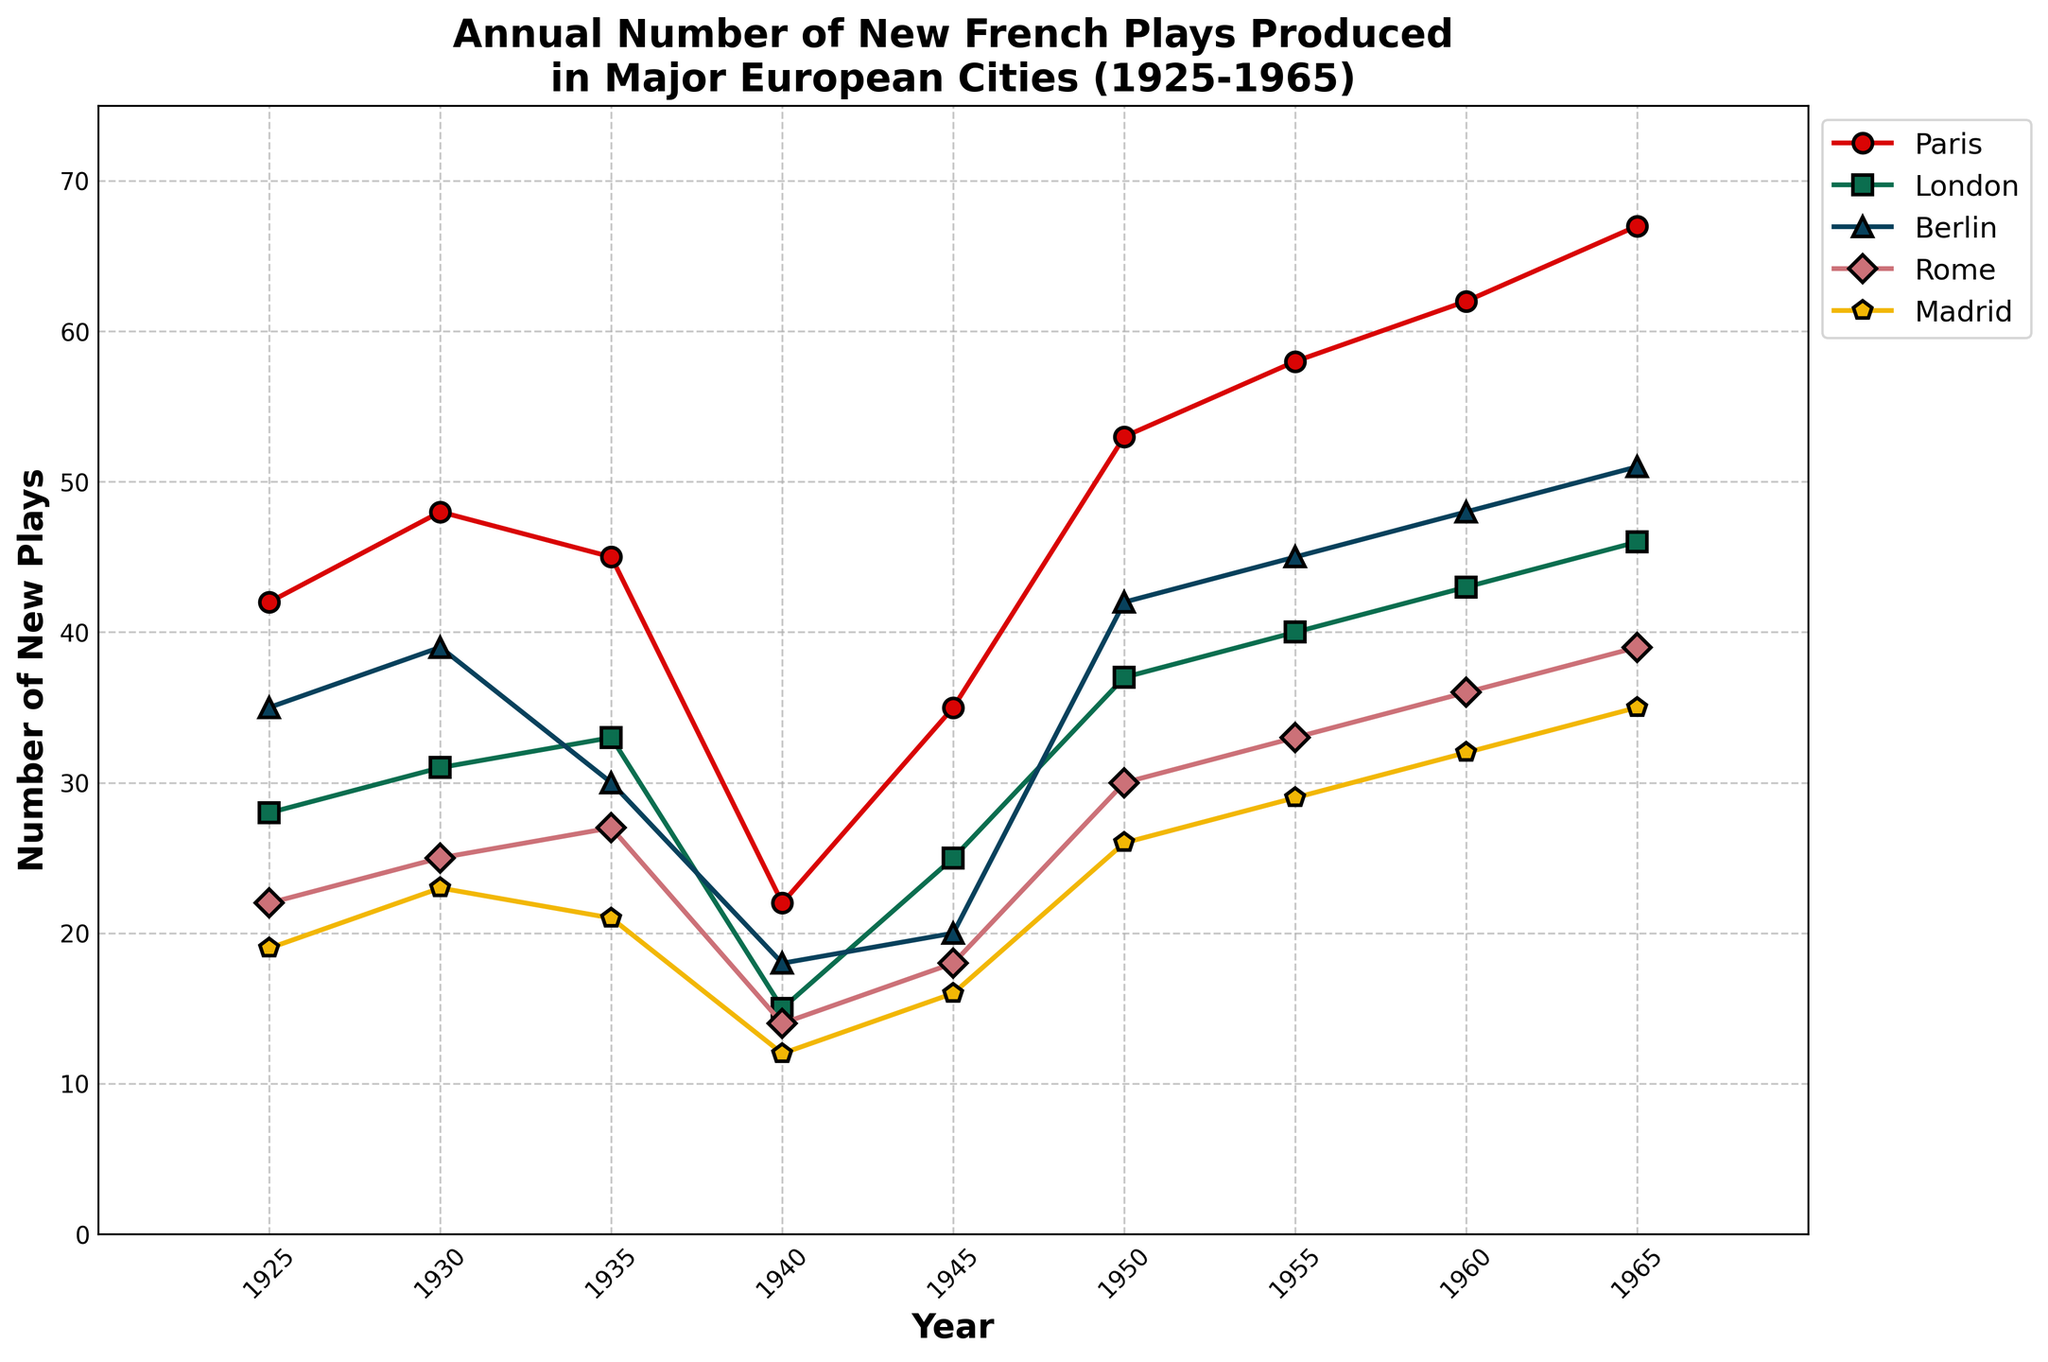What trend do you observe in the number of new plays produced in Paris from 1925 to 1965? From the graph, the number of new plays produced in Paris generally increases over the years, with a noticeable dip around 1940 likely due to World War II. The trend then returns to the upward trajectory post-1945, peaking at 67 plays in 1965.
Answer: The number of new plays in Paris generally increased Which city produced the fewest new plays in 1940? Referring to the graph, in 1940, Madrid produced the fewest new plays compared to Paris, London, Berlin, and Rome, indicated by the lowest point on the graph.
Answer: Madrid By how many plays did Paris surpass London in 1965? In 1965, the graph shows that Paris produced 67 plays while London produced 46 plays. Subtracting these values gives 67 - 46 = 21 plays.
Answer: 21 plays In which year did Berlin first produce more plays than London? By examining the graph, in 1930, Berlin produced 39 plays while London produced 31 plays, making this the first year Berlin surpassed London.
Answer: 1930 Which city had the steepest increase in the number of new plays produced between 1945 and 1950? The graph shows that Paris had the steepest increase; Paris went from 35 plays in 1945 to 53 plays in 1950, an increase of 18 plays. Berlin and London had smaller increases during the same period.
Answer: Paris How many new plays were produced in total by Rome and Madrid in 1955? Looking at the graph, Rome produced 33 and Madrid produced 29 new plays in 1955. Adding them together equals 33 + 29 = 62 new plays.
Answer: 62 plays What is the difference in the number of new plays produced in Paris between 1925 and 1965? According to the graph, Paris produced 42 plays in 1925 and 67 plays in 1965. The difference is 67 - 42 = 25 plays.
Answer: 25 plays Which city's production of new plays was least affected during World War II (1940-1945)? Observing the graph, Rome's production decreased slightly from 14 to 18, but the change was less pronounced compared to other cities like Paris, Berlin, London, and Madrid.
Answer: Rome How many more plays did Paris produce than Berlin in 1955? The graph shows Paris produced 58 plays, and Berlin produced 45 plays in 1955. Subtracting these values gives 58 - 45 = 13 plays.
Answer: 13 plays Evaluate the average number of plays produced in Paris over the decades shown in the graph. To calculate this, sum up the number of plays produced in Paris for all years provided ((42 + 48 + 45 + 22 + 35 + 53 + 58 + 62 + 67) = 432), then divide by the number of years (9). The average is 432 / 9 = 48 plays.
Answer: 48 plays 